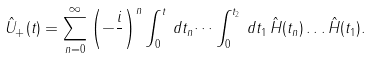Convert formula to latex. <formula><loc_0><loc_0><loc_500><loc_500>\hat { U } _ { + } ( t ) = \sum _ { n = 0 } ^ { \infty } \left ( - \frac { i } { } \right ) ^ { n } \int _ { 0 } ^ { t } \, d t _ { n } \dots \int _ { 0 } ^ { t _ { 2 } } \, d t _ { 1 } \, \hat { H } ( t _ { n } ) \dots \hat { H } ( t _ { 1 } ) .</formula> 